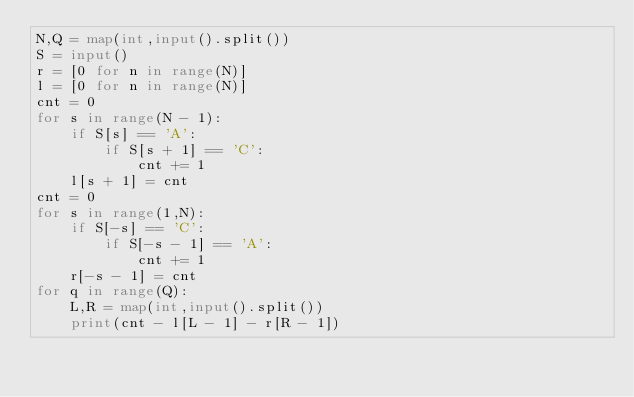Convert code to text. <code><loc_0><loc_0><loc_500><loc_500><_Python_>N,Q = map(int,input().split())
S = input()
r = [0 for n in range(N)]
l = [0 for n in range(N)]
cnt = 0
for s in range(N - 1):
	if S[s] == 'A':
		if S[s + 1] == 'C':
			cnt += 1
	l[s + 1] = cnt
cnt = 0
for s in range(1,N):
	if S[-s] == 'C':
		if S[-s - 1] == 'A':
			cnt += 1
	r[-s - 1] = cnt
for q in range(Q):
	L,R = map(int,input().split())
	print(cnt - l[L - 1] - r[R - 1])
</code> 